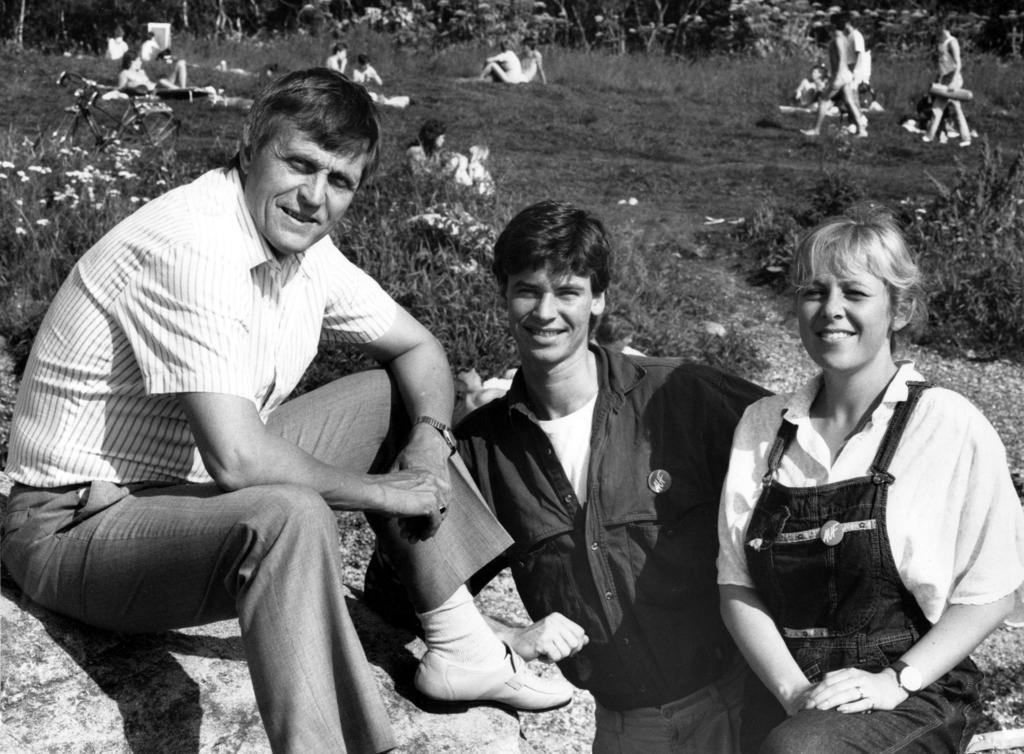Can you describe this image briefly? This is a black and white image. We can see there are three persons sitting on a rock. Behind the three persons, there is grass, groups of people, a bicycle and trees. 